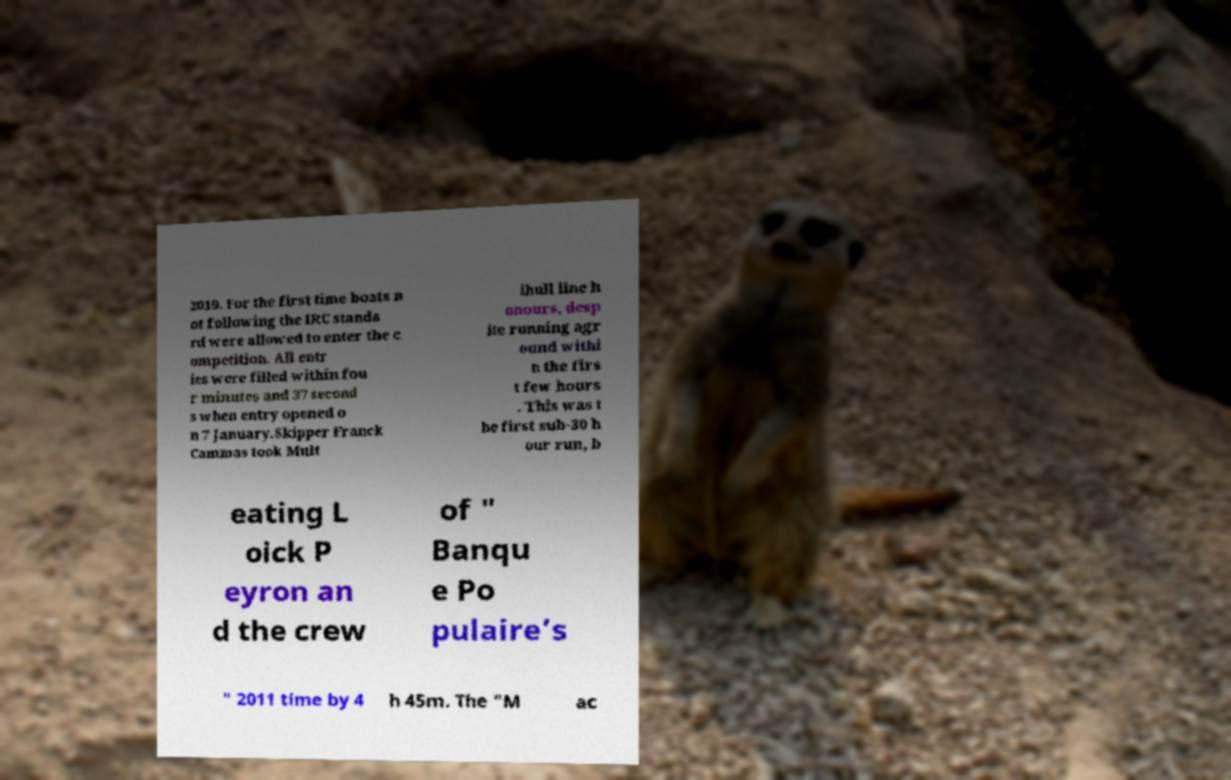There's text embedded in this image that I need extracted. Can you transcribe it verbatim? 2019. For the first time boats n ot following the IRC standa rd were allowed to enter the c ompetition. All entr ies were filled within fou r minutes and 37 second s when entry opened o n 7 January.Skipper Franck Cammas took Mult ihull line h onours, desp ite running agr ound withi n the firs t few hours . This was t he first sub-30 h our run, b eating L oick P eyron an d the crew of " Banqu e Po pulaire’s " 2011 time by 4 h 45m. The "M ac 